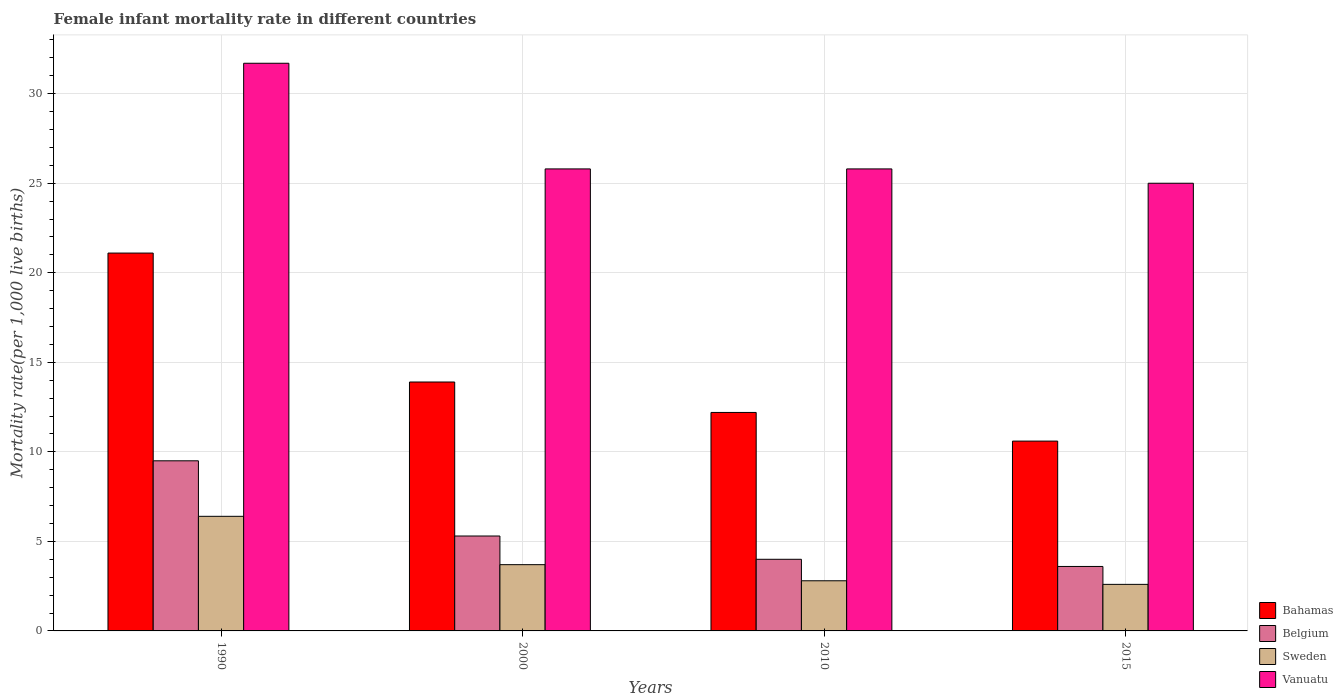How many different coloured bars are there?
Make the answer very short. 4. How many groups of bars are there?
Make the answer very short. 4. What is the label of the 2nd group of bars from the left?
Offer a terse response. 2000. In how many cases, is the number of bars for a given year not equal to the number of legend labels?
Ensure brevity in your answer.  0. What is the female infant mortality rate in Sweden in 2015?
Your answer should be very brief. 2.6. Across all years, what is the maximum female infant mortality rate in Vanuatu?
Ensure brevity in your answer.  31.7. In which year was the female infant mortality rate in Belgium minimum?
Offer a very short reply. 2015. What is the total female infant mortality rate in Sweden in the graph?
Offer a terse response. 15.5. What is the difference between the female infant mortality rate in Bahamas in 1990 and that in 2010?
Provide a succinct answer. 8.9. What is the difference between the female infant mortality rate in Sweden in 2010 and the female infant mortality rate in Belgium in 2015?
Offer a terse response. -0.8. What is the average female infant mortality rate in Belgium per year?
Offer a terse response. 5.6. In the year 2015, what is the difference between the female infant mortality rate in Belgium and female infant mortality rate in Vanuatu?
Offer a terse response. -21.4. In how many years, is the female infant mortality rate in Vanuatu greater than 30?
Provide a succinct answer. 1. What is the ratio of the female infant mortality rate in Belgium in 2000 to that in 2015?
Make the answer very short. 1.47. What is the difference between the highest and the second highest female infant mortality rate in Vanuatu?
Ensure brevity in your answer.  5.9. Is the sum of the female infant mortality rate in Belgium in 2000 and 2015 greater than the maximum female infant mortality rate in Bahamas across all years?
Your response must be concise. No. Is it the case that in every year, the sum of the female infant mortality rate in Belgium and female infant mortality rate in Sweden is greater than the sum of female infant mortality rate in Bahamas and female infant mortality rate in Vanuatu?
Offer a very short reply. No. What does the 4th bar from the left in 1990 represents?
Your answer should be compact. Vanuatu. What does the 3rd bar from the right in 2010 represents?
Keep it short and to the point. Belgium. What is the difference between two consecutive major ticks on the Y-axis?
Your answer should be very brief. 5. How many legend labels are there?
Provide a succinct answer. 4. How are the legend labels stacked?
Give a very brief answer. Vertical. What is the title of the graph?
Ensure brevity in your answer.  Female infant mortality rate in different countries. What is the label or title of the Y-axis?
Your answer should be very brief. Mortality rate(per 1,0 live births). What is the Mortality rate(per 1,000 live births) in Bahamas in 1990?
Your answer should be compact. 21.1. What is the Mortality rate(per 1,000 live births) in Sweden in 1990?
Offer a very short reply. 6.4. What is the Mortality rate(per 1,000 live births) in Vanuatu in 1990?
Provide a succinct answer. 31.7. What is the Mortality rate(per 1,000 live births) in Bahamas in 2000?
Ensure brevity in your answer.  13.9. What is the Mortality rate(per 1,000 live births) in Sweden in 2000?
Make the answer very short. 3.7. What is the Mortality rate(per 1,000 live births) in Vanuatu in 2000?
Provide a short and direct response. 25.8. What is the Mortality rate(per 1,000 live births) in Bahamas in 2010?
Your answer should be compact. 12.2. What is the Mortality rate(per 1,000 live births) in Belgium in 2010?
Provide a short and direct response. 4. What is the Mortality rate(per 1,000 live births) of Sweden in 2010?
Offer a very short reply. 2.8. What is the Mortality rate(per 1,000 live births) in Vanuatu in 2010?
Keep it short and to the point. 25.8. What is the Mortality rate(per 1,000 live births) of Sweden in 2015?
Provide a succinct answer. 2.6. What is the Mortality rate(per 1,000 live births) of Vanuatu in 2015?
Ensure brevity in your answer.  25. Across all years, what is the maximum Mortality rate(per 1,000 live births) in Bahamas?
Ensure brevity in your answer.  21.1. Across all years, what is the maximum Mortality rate(per 1,000 live births) in Belgium?
Keep it short and to the point. 9.5. Across all years, what is the maximum Mortality rate(per 1,000 live births) of Sweden?
Offer a very short reply. 6.4. Across all years, what is the maximum Mortality rate(per 1,000 live births) of Vanuatu?
Ensure brevity in your answer.  31.7. Across all years, what is the minimum Mortality rate(per 1,000 live births) in Belgium?
Make the answer very short. 3.6. Across all years, what is the minimum Mortality rate(per 1,000 live births) of Sweden?
Your response must be concise. 2.6. Across all years, what is the minimum Mortality rate(per 1,000 live births) of Vanuatu?
Ensure brevity in your answer.  25. What is the total Mortality rate(per 1,000 live births) of Bahamas in the graph?
Ensure brevity in your answer.  57.8. What is the total Mortality rate(per 1,000 live births) of Belgium in the graph?
Your answer should be very brief. 22.4. What is the total Mortality rate(per 1,000 live births) of Sweden in the graph?
Ensure brevity in your answer.  15.5. What is the total Mortality rate(per 1,000 live births) of Vanuatu in the graph?
Provide a succinct answer. 108.3. What is the difference between the Mortality rate(per 1,000 live births) of Bahamas in 1990 and that in 2015?
Offer a terse response. 10.5. What is the difference between the Mortality rate(per 1,000 live births) in Belgium in 1990 and that in 2015?
Your response must be concise. 5.9. What is the difference between the Mortality rate(per 1,000 live births) of Sweden in 1990 and that in 2015?
Offer a very short reply. 3.8. What is the difference between the Mortality rate(per 1,000 live births) in Vanuatu in 1990 and that in 2015?
Provide a succinct answer. 6.7. What is the difference between the Mortality rate(per 1,000 live births) of Bahamas in 2000 and that in 2015?
Provide a succinct answer. 3.3. What is the difference between the Mortality rate(per 1,000 live births) in Belgium in 2000 and that in 2015?
Your answer should be compact. 1.7. What is the difference between the Mortality rate(per 1,000 live births) of Sweden in 2000 and that in 2015?
Give a very brief answer. 1.1. What is the difference between the Mortality rate(per 1,000 live births) of Vanuatu in 2000 and that in 2015?
Your response must be concise. 0.8. What is the difference between the Mortality rate(per 1,000 live births) of Bahamas in 2010 and that in 2015?
Give a very brief answer. 1.6. What is the difference between the Mortality rate(per 1,000 live births) of Vanuatu in 2010 and that in 2015?
Provide a succinct answer. 0.8. What is the difference between the Mortality rate(per 1,000 live births) of Bahamas in 1990 and the Mortality rate(per 1,000 live births) of Belgium in 2000?
Make the answer very short. 15.8. What is the difference between the Mortality rate(per 1,000 live births) of Bahamas in 1990 and the Mortality rate(per 1,000 live births) of Sweden in 2000?
Your answer should be very brief. 17.4. What is the difference between the Mortality rate(per 1,000 live births) in Bahamas in 1990 and the Mortality rate(per 1,000 live births) in Vanuatu in 2000?
Offer a terse response. -4.7. What is the difference between the Mortality rate(per 1,000 live births) of Belgium in 1990 and the Mortality rate(per 1,000 live births) of Vanuatu in 2000?
Your answer should be compact. -16.3. What is the difference between the Mortality rate(per 1,000 live births) in Sweden in 1990 and the Mortality rate(per 1,000 live births) in Vanuatu in 2000?
Offer a terse response. -19.4. What is the difference between the Mortality rate(per 1,000 live births) in Bahamas in 1990 and the Mortality rate(per 1,000 live births) in Sweden in 2010?
Provide a succinct answer. 18.3. What is the difference between the Mortality rate(per 1,000 live births) in Belgium in 1990 and the Mortality rate(per 1,000 live births) in Vanuatu in 2010?
Offer a terse response. -16.3. What is the difference between the Mortality rate(per 1,000 live births) in Sweden in 1990 and the Mortality rate(per 1,000 live births) in Vanuatu in 2010?
Offer a very short reply. -19.4. What is the difference between the Mortality rate(per 1,000 live births) of Bahamas in 1990 and the Mortality rate(per 1,000 live births) of Belgium in 2015?
Your answer should be very brief. 17.5. What is the difference between the Mortality rate(per 1,000 live births) of Bahamas in 1990 and the Mortality rate(per 1,000 live births) of Sweden in 2015?
Give a very brief answer. 18.5. What is the difference between the Mortality rate(per 1,000 live births) of Bahamas in 1990 and the Mortality rate(per 1,000 live births) of Vanuatu in 2015?
Offer a terse response. -3.9. What is the difference between the Mortality rate(per 1,000 live births) in Belgium in 1990 and the Mortality rate(per 1,000 live births) in Vanuatu in 2015?
Provide a succinct answer. -15.5. What is the difference between the Mortality rate(per 1,000 live births) of Sweden in 1990 and the Mortality rate(per 1,000 live births) of Vanuatu in 2015?
Your response must be concise. -18.6. What is the difference between the Mortality rate(per 1,000 live births) of Bahamas in 2000 and the Mortality rate(per 1,000 live births) of Belgium in 2010?
Offer a very short reply. 9.9. What is the difference between the Mortality rate(per 1,000 live births) of Bahamas in 2000 and the Mortality rate(per 1,000 live births) of Vanuatu in 2010?
Offer a very short reply. -11.9. What is the difference between the Mortality rate(per 1,000 live births) of Belgium in 2000 and the Mortality rate(per 1,000 live births) of Vanuatu in 2010?
Provide a succinct answer. -20.5. What is the difference between the Mortality rate(per 1,000 live births) in Sweden in 2000 and the Mortality rate(per 1,000 live births) in Vanuatu in 2010?
Make the answer very short. -22.1. What is the difference between the Mortality rate(per 1,000 live births) of Bahamas in 2000 and the Mortality rate(per 1,000 live births) of Sweden in 2015?
Keep it short and to the point. 11.3. What is the difference between the Mortality rate(per 1,000 live births) in Bahamas in 2000 and the Mortality rate(per 1,000 live births) in Vanuatu in 2015?
Ensure brevity in your answer.  -11.1. What is the difference between the Mortality rate(per 1,000 live births) of Belgium in 2000 and the Mortality rate(per 1,000 live births) of Vanuatu in 2015?
Your answer should be very brief. -19.7. What is the difference between the Mortality rate(per 1,000 live births) of Sweden in 2000 and the Mortality rate(per 1,000 live births) of Vanuatu in 2015?
Make the answer very short. -21.3. What is the difference between the Mortality rate(per 1,000 live births) in Belgium in 2010 and the Mortality rate(per 1,000 live births) in Sweden in 2015?
Give a very brief answer. 1.4. What is the difference between the Mortality rate(per 1,000 live births) in Belgium in 2010 and the Mortality rate(per 1,000 live births) in Vanuatu in 2015?
Ensure brevity in your answer.  -21. What is the difference between the Mortality rate(per 1,000 live births) in Sweden in 2010 and the Mortality rate(per 1,000 live births) in Vanuatu in 2015?
Keep it short and to the point. -22.2. What is the average Mortality rate(per 1,000 live births) of Bahamas per year?
Provide a short and direct response. 14.45. What is the average Mortality rate(per 1,000 live births) in Belgium per year?
Your answer should be very brief. 5.6. What is the average Mortality rate(per 1,000 live births) in Sweden per year?
Your answer should be very brief. 3.88. What is the average Mortality rate(per 1,000 live births) of Vanuatu per year?
Offer a terse response. 27.07. In the year 1990, what is the difference between the Mortality rate(per 1,000 live births) of Bahamas and Mortality rate(per 1,000 live births) of Sweden?
Your response must be concise. 14.7. In the year 1990, what is the difference between the Mortality rate(per 1,000 live births) of Belgium and Mortality rate(per 1,000 live births) of Sweden?
Offer a terse response. 3.1. In the year 1990, what is the difference between the Mortality rate(per 1,000 live births) in Belgium and Mortality rate(per 1,000 live births) in Vanuatu?
Your response must be concise. -22.2. In the year 1990, what is the difference between the Mortality rate(per 1,000 live births) in Sweden and Mortality rate(per 1,000 live births) in Vanuatu?
Your response must be concise. -25.3. In the year 2000, what is the difference between the Mortality rate(per 1,000 live births) of Bahamas and Mortality rate(per 1,000 live births) of Belgium?
Ensure brevity in your answer.  8.6. In the year 2000, what is the difference between the Mortality rate(per 1,000 live births) of Bahamas and Mortality rate(per 1,000 live births) of Sweden?
Your response must be concise. 10.2. In the year 2000, what is the difference between the Mortality rate(per 1,000 live births) in Belgium and Mortality rate(per 1,000 live births) in Vanuatu?
Make the answer very short. -20.5. In the year 2000, what is the difference between the Mortality rate(per 1,000 live births) in Sweden and Mortality rate(per 1,000 live births) in Vanuatu?
Your answer should be compact. -22.1. In the year 2010, what is the difference between the Mortality rate(per 1,000 live births) of Bahamas and Mortality rate(per 1,000 live births) of Belgium?
Offer a terse response. 8.2. In the year 2010, what is the difference between the Mortality rate(per 1,000 live births) in Bahamas and Mortality rate(per 1,000 live births) in Vanuatu?
Make the answer very short. -13.6. In the year 2010, what is the difference between the Mortality rate(per 1,000 live births) of Belgium and Mortality rate(per 1,000 live births) of Sweden?
Ensure brevity in your answer.  1.2. In the year 2010, what is the difference between the Mortality rate(per 1,000 live births) of Belgium and Mortality rate(per 1,000 live births) of Vanuatu?
Ensure brevity in your answer.  -21.8. In the year 2010, what is the difference between the Mortality rate(per 1,000 live births) in Sweden and Mortality rate(per 1,000 live births) in Vanuatu?
Keep it short and to the point. -23. In the year 2015, what is the difference between the Mortality rate(per 1,000 live births) in Bahamas and Mortality rate(per 1,000 live births) in Belgium?
Offer a very short reply. 7. In the year 2015, what is the difference between the Mortality rate(per 1,000 live births) in Bahamas and Mortality rate(per 1,000 live births) in Vanuatu?
Your answer should be compact. -14.4. In the year 2015, what is the difference between the Mortality rate(per 1,000 live births) of Belgium and Mortality rate(per 1,000 live births) of Sweden?
Your answer should be compact. 1. In the year 2015, what is the difference between the Mortality rate(per 1,000 live births) of Belgium and Mortality rate(per 1,000 live births) of Vanuatu?
Offer a very short reply. -21.4. In the year 2015, what is the difference between the Mortality rate(per 1,000 live births) of Sweden and Mortality rate(per 1,000 live births) of Vanuatu?
Your answer should be compact. -22.4. What is the ratio of the Mortality rate(per 1,000 live births) of Bahamas in 1990 to that in 2000?
Your answer should be very brief. 1.52. What is the ratio of the Mortality rate(per 1,000 live births) of Belgium in 1990 to that in 2000?
Your answer should be very brief. 1.79. What is the ratio of the Mortality rate(per 1,000 live births) in Sweden in 1990 to that in 2000?
Provide a short and direct response. 1.73. What is the ratio of the Mortality rate(per 1,000 live births) in Vanuatu in 1990 to that in 2000?
Your answer should be compact. 1.23. What is the ratio of the Mortality rate(per 1,000 live births) in Bahamas in 1990 to that in 2010?
Provide a short and direct response. 1.73. What is the ratio of the Mortality rate(per 1,000 live births) of Belgium in 1990 to that in 2010?
Provide a short and direct response. 2.38. What is the ratio of the Mortality rate(per 1,000 live births) in Sweden in 1990 to that in 2010?
Provide a succinct answer. 2.29. What is the ratio of the Mortality rate(per 1,000 live births) of Vanuatu in 1990 to that in 2010?
Provide a short and direct response. 1.23. What is the ratio of the Mortality rate(per 1,000 live births) of Bahamas in 1990 to that in 2015?
Ensure brevity in your answer.  1.99. What is the ratio of the Mortality rate(per 1,000 live births) in Belgium in 1990 to that in 2015?
Provide a short and direct response. 2.64. What is the ratio of the Mortality rate(per 1,000 live births) of Sweden in 1990 to that in 2015?
Provide a short and direct response. 2.46. What is the ratio of the Mortality rate(per 1,000 live births) in Vanuatu in 1990 to that in 2015?
Keep it short and to the point. 1.27. What is the ratio of the Mortality rate(per 1,000 live births) of Bahamas in 2000 to that in 2010?
Your answer should be compact. 1.14. What is the ratio of the Mortality rate(per 1,000 live births) in Belgium in 2000 to that in 2010?
Keep it short and to the point. 1.32. What is the ratio of the Mortality rate(per 1,000 live births) in Sweden in 2000 to that in 2010?
Provide a succinct answer. 1.32. What is the ratio of the Mortality rate(per 1,000 live births) in Vanuatu in 2000 to that in 2010?
Make the answer very short. 1. What is the ratio of the Mortality rate(per 1,000 live births) in Bahamas in 2000 to that in 2015?
Provide a succinct answer. 1.31. What is the ratio of the Mortality rate(per 1,000 live births) in Belgium in 2000 to that in 2015?
Offer a terse response. 1.47. What is the ratio of the Mortality rate(per 1,000 live births) in Sweden in 2000 to that in 2015?
Provide a short and direct response. 1.42. What is the ratio of the Mortality rate(per 1,000 live births) in Vanuatu in 2000 to that in 2015?
Give a very brief answer. 1.03. What is the ratio of the Mortality rate(per 1,000 live births) in Bahamas in 2010 to that in 2015?
Make the answer very short. 1.15. What is the ratio of the Mortality rate(per 1,000 live births) in Belgium in 2010 to that in 2015?
Ensure brevity in your answer.  1.11. What is the ratio of the Mortality rate(per 1,000 live births) in Sweden in 2010 to that in 2015?
Keep it short and to the point. 1.08. What is the ratio of the Mortality rate(per 1,000 live births) of Vanuatu in 2010 to that in 2015?
Give a very brief answer. 1.03. What is the difference between the highest and the lowest Mortality rate(per 1,000 live births) in Sweden?
Offer a terse response. 3.8. 